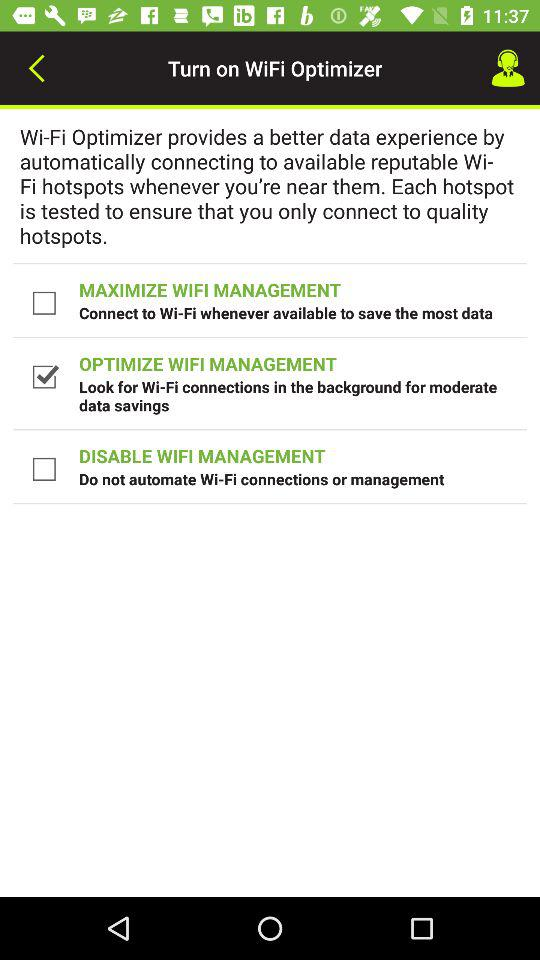What is the current status of "DISABLE WIFI MANAGEMENT"? The status is "off". 